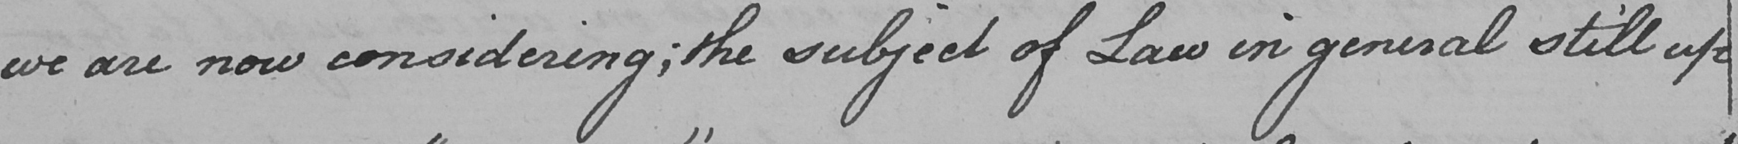Please provide the text content of this handwritten line. we are now considering ; the subject of Law in general still upon 